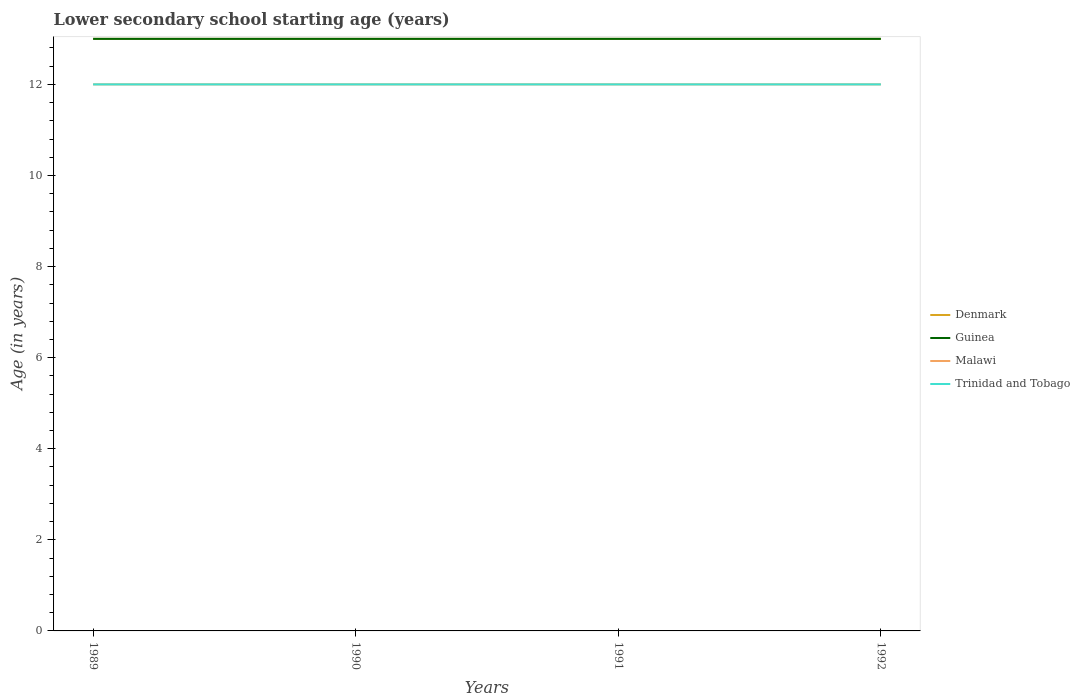How many different coloured lines are there?
Make the answer very short. 4. Does the line corresponding to Trinidad and Tobago intersect with the line corresponding to Guinea?
Ensure brevity in your answer.  No. Across all years, what is the maximum lower secondary school starting age of children in Trinidad and Tobago?
Ensure brevity in your answer.  12. In which year was the lower secondary school starting age of children in Denmark maximum?
Offer a terse response. 1989. What is the total lower secondary school starting age of children in Trinidad and Tobago in the graph?
Provide a short and direct response. 0. What is the difference between the highest and the second highest lower secondary school starting age of children in Trinidad and Tobago?
Provide a short and direct response. 0. Is the lower secondary school starting age of children in Denmark strictly greater than the lower secondary school starting age of children in Malawi over the years?
Keep it short and to the point. No. Does the graph contain grids?
Offer a very short reply. No. How many legend labels are there?
Your response must be concise. 4. How are the legend labels stacked?
Offer a terse response. Vertical. What is the title of the graph?
Offer a terse response. Lower secondary school starting age (years). What is the label or title of the Y-axis?
Ensure brevity in your answer.  Age (in years). What is the Age (in years) in Malawi in 1989?
Provide a short and direct response. 12. What is the Age (in years) of Trinidad and Tobago in 1989?
Your response must be concise. 12. What is the Age (in years) of Denmark in 1990?
Your response must be concise. 13. What is the Age (in years) of Malawi in 1990?
Provide a succinct answer. 12. What is the Age (in years) in Guinea in 1991?
Make the answer very short. 13. What is the Age (in years) in Trinidad and Tobago in 1991?
Offer a very short reply. 12. What is the Age (in years) of Denmark in 1992?
Keep it short and to the point. 13. What is the Age (in years) of Guinea in 1992?
Your answer should be very brief. 13. What is the Age (in years) of Malawi in 1992?
Offer a terse response. 12. What is the Age (in years) in Trinidad and Tobago in 1992?
Ensure brevity in your answer.  12. Across all years, what is the maximum Age (in years) in Denmark?
Your response must be concise. 13. Across all years, what is the maximum Age (in years) of Trinidad and Tobago?
Your answer should be very brief. 12. Across all years, what is the minimum Age (in years) of Denmark?
Ensure brevity in your answer.  13. Across all years, what is the minimum Age (in years) in Guinea?
Provide a succinct answer. 13. Across all years, what is the minimum Age (in years) in Trinidad and Tobago?
Keep it short and to the point. 12. What is the total Age (in years) in Guinea in the graph?
Offer a very short reply. 52. What is the total Age (in years) in Malawi in the graph?
Ensure brevity in your answer.  48. What is the total Age (in years) in Trinidad and Tobago in the graph?
Keep it short and to the point. 48. What is the difference between the Age (in years) in Guinea in 1989 and that in 1990?
Your answer should be compact. 0. What is the difference between the Age (in years) in Malawi in 1989 and that in 1990?
Provide a succinct answer. 0. What is the difference between the Age (in years) of Trinidad and Tobago in 1989 and that in 1990?
Keep it short and to the point. 0. What is the difference between the Age (in years) in Guinea in 1989 and that in 1991?
Give a very brief answer. 0. What is the difference between the Age (in years) in Malawi in 1989 and that in 1991?
Offer a very short reply. 0. What is the difference between the Age (in years) in Denmark in 1989 and that in 1992?
Offer a terse response. 0. What is the difference between the Age (in years) in Malawi in 1989 and that in 1992?
Your answer should be compact. 0. What is the difference between the Age (in years) of Denmark in 1990 and that in 1992?
Ensure brevity in your answer.  0. What is the difference between the Age (in years) in Malawi in 1990 and that in 1992?
Make the answer very short. 0. What is the difference between the Age (in years) in Trinidad and Tobago in 1990 and that in 1992?
Give a very brief answer. 0. What is the difference between the Age (in years) in Malawi in 1991 and that in 1992?
Your response must be concise. 0. What is the difference between the Age (in years) in Denmark in 1989 and the Age (in years) in Malawi in 1990?
Your answer should be compact. 1. What is the difference between the Age (in years) in Malawi in 1989 and the Age (in years) in Trinidad and Tobago in 1990?
Keep it short and to the point. 0. What is the difference between the Age (in years) in Denmark in 1989 and the Age (in years) in Guinea in 1991?
Offer a very short reply. 0. What is the difference between the Age (in years) in Denmark in 1989 and the Age (in years) in Malawi in 1991?
Make the answer very short. 1. What is the difference between the Age (in years) of Denmark in 1989 and the Age (in years) of Trinidad and Tobago in 1991?
Provide a short and direct response. 1. What is the difference between the Age (in years) of Guinea in 1989 and the Age (in years) of Trinidad and Tobago in 1991?
Keep it short and to the point. 1. What is the difference between the Age (in years) in Denmark in 1989 and the Age (in years) in Guinea in 1992?
Your answer should be compact. 0. What is the difference between the Age (in years) of Denmark in 1989 and the Age (in years) of Malawi in 1992?
Keep it short and to the point. 1. What is the difference between the Age (in years) of Denmark in 1989 and the Age (in years) of Trinidad and Tobago in 1992?
Offer a very short reply. 1. What is the difference between the Age (in years) in Guinea in 1989 and the Age (in years) in Malawi in 1992?
Provide a succinct answer. 1. What is the difference between the Age (in years) of Guinea in 1989 and the Age (in years) of Trinidad and Tobago in 1992?
Ensure brevity in your answer.  1. What is the difference between the Age (in years) in Denmark in 1990 and the Age (in years) in Guinea in 1991?
Offer a very short reply. 0. What is the difference between the Age (in years) of Denmark in 1990 and the Age (in years) of Malawi in 1991?
Your response must be concise. 1. What is the difference between the Age (in years) of Denmark in 1990 and the Age (in years) of Trinidad and Tobago in 1991?
Offer a terse response. 1. What is the difference between the Age (in years) of Guinea in 1990 and the Age (in years) of Malawi in 1991?
Give a very brief answer. 1. What is the difference between the Age (in years) of Denmark in 1990 and the Age (in years) of Guinea in 1992?
Give a very brief answer. 0. What is the difference between the Age (in years) in Guinea in 1990 and the Age (in years) in Malawi in 1992?
Keep it short and to the point. 1. What is the difference between the Age (in years) in Guinea in 1990 and the Age (in years) in Trinidad and Tobago in 1992?
Your answer should be compact. 1. What is the difference between the Age (in years) of Malawi in 1990 and the Age (in years) of Trinidad and Tobago in 1992?
Your answer should be compact. 0. What is the difference between the Age (in years) in Denmark in 1991 and the Age (in years) in Guinea in 1992?
Make the answer very short. 0. What is the difference between the Age (in years) of Denmark in 1991 and the Age (in years) of Malawi in 1992?
Your answer should be compact. 1. What is the average Age (in years) of Denmark per year?
Keep it short and to the point. 13. What is the average Age (in years) in Guinea per year?
Provide a succinct answer. 13. What is the average Age (in years) in Trinidad and Tobago per year?
Your answer should be very brief. 12. In the year 1989, what is the difference between the Age (in years) of Guinea and Age (in years) of Malawi?
Make the answer very short. 1. In the year 1989, what is the difference between the Age (in years) in Guinea and Age (in years) in Trinidad and Tobago?
Ensure brevity in your answer.  1. In the year 1989, what is the difference between the Age (in years) of Malawi and Age (in years) of Trinidad and Tobago?
Make the answer very short. 0. In the year 1990, what is the difference between the Age (in years) of Denmark and Age (in years) of Malawi?
Your response must be concise. 1. In the year 1990, what is the difference between the Age (in years) in Guinea and Age (in years) in Trinidad and Tobago?
Your answer should be compact. 1. In the year 1990, what is the difference between the Age (in years) of Malawi and Age (in years) of Trinidad and Tobago?
Provide a succinct answer. 0. In the year 1991, what is the difference between the Age (in years) in Denmark and Age (in years) in Guinea?
Offer a terse response. 0. In the year 1991, what is the difference between the Age (in years) in Denmark and Age (in years) in Malawi?
Provide a succinct answer. 1. In the year 1991, what is the difference between the Age (in years) of Guinea and Age (in years) of Malawi?
Your answer should be very brief. 1. In the year 1991, what is the difference between the Age (in years) in Malawi and Age (in years) in Trinidad and Tobago?
Your answer should be compact. 0. In the year 1992, what is the difference between the Age (in years) in Denmark and Age (in years) in Guinea?
Keep it short and to the point. 0. In the year 1992, what is the difference between the Age (in years) of Denmark and Age (in years) of Malawi?
Ensure brevity in your answer.  1. In the year 1992, what is the difference between the Age (in years) of Malawi and Age (in years) of Trinidad and Tobago?
Provide a short and direct response. 0. What is the ratio of the Age (in years) in Denmark in 1989 to that in 1990?
Your answer should be compact. 1. What is the ratio of the Age (in years) in Malawi in 1989 to that in 1990?
Ensure brevity in your answer.  1. What is the ratio of the Age (in years) in Denmark in 1989 to that in 1991?
Keep it short and to the point. 1. What is the ratio of the Age (in years) of Malawi in 1989 to that in 1991?
Offer a very short reply. 1. What is the ratio of the Age (in years) in Trinidad and Tobago in 1989 to that in 1991?
Make the answer very short. 1. What is the ratio of the Age (in years) of Malawi in 1989 to that in 1992?
Your response must be concise. 1. What is the ratio of the Age (in years) of Trinidad and Tobago in 1989 to that in 1992?
Ensure brevity in your answer.  1. What is the ratio of the Age (in years) in Denmark in 1990 to that in 1991?
Make the answer very short. 1. What is the ratio of the Age (in years) in Malawi in 1990 to that in 1991?
Provide a succinct answer. 1. What is the ratio of the Age (in years) in Guinea in 1990 to that in 1992?
Your answer should be very brief. 1. What is the ratio of the Age (in years) of Denmark in 1991 to that in 1992?
Provide a succinct answer. 1. What is the difference between the highest and the lowest Age (in years) in Denmark?
Offer a terse response. 0. What is the difference between the highest and the lowest Age (in years) of Guinea?
Give a very brief answer. 0. 